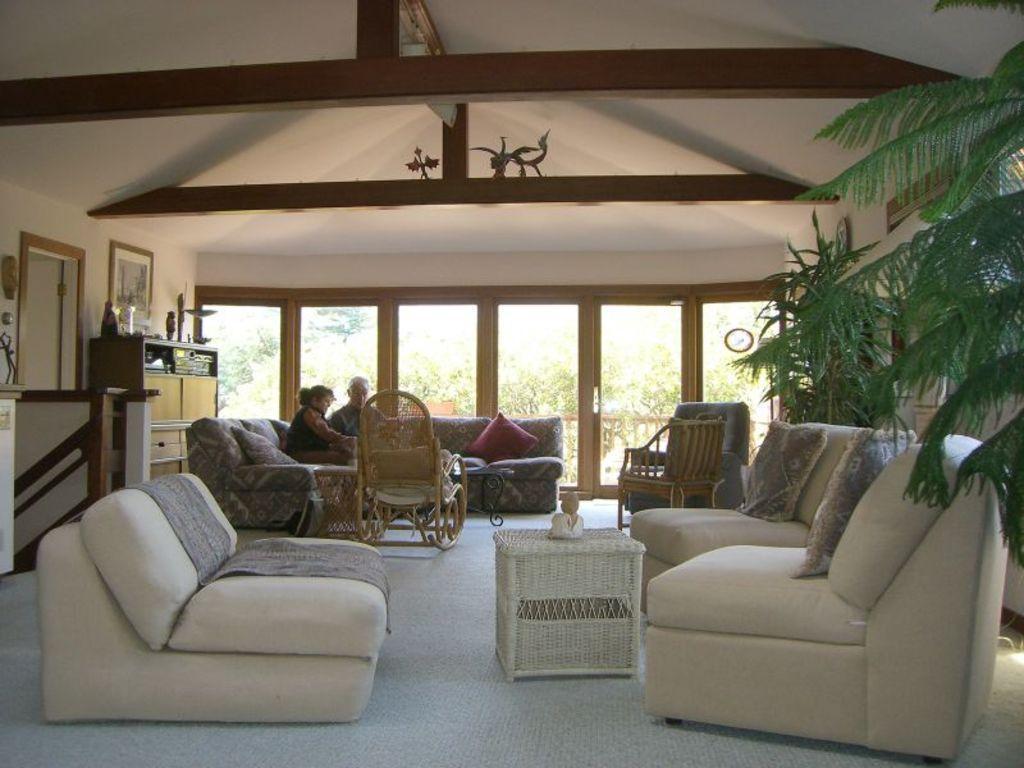Can you describe this image briefly? There are sofas in front of a table and there is a tree in the right corner and there are two people sitting in a sofa in the background. 